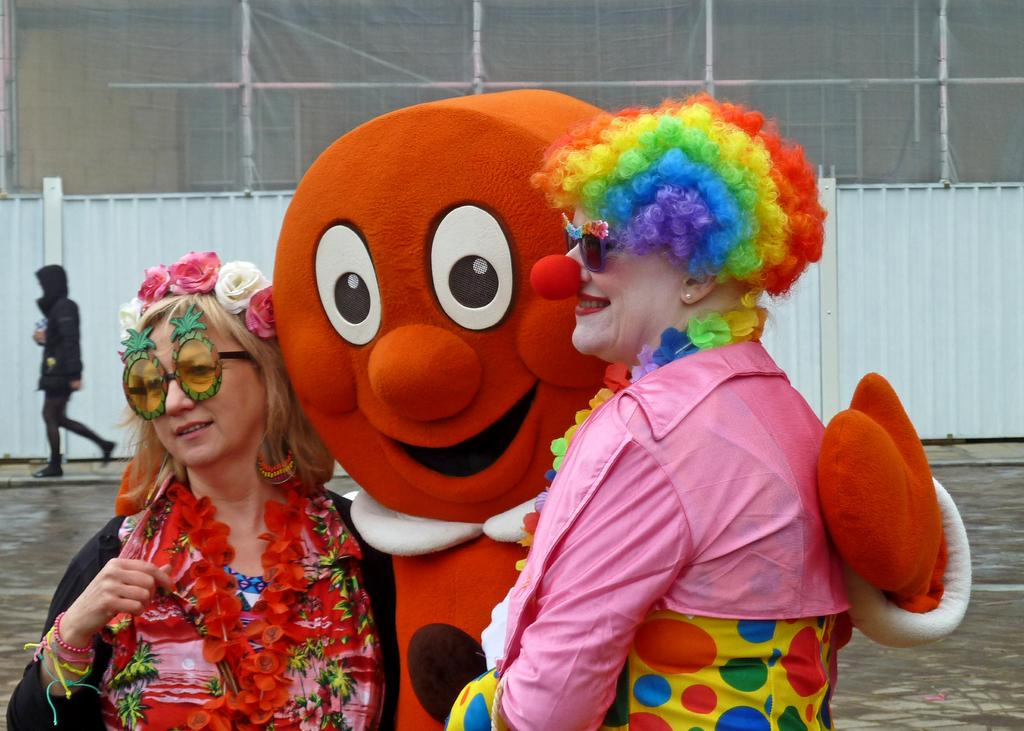What are the people in the image wearing? The people in the image are wearing costumes. Where are the people standing in the image? The people are standing on a pavement. What can be seen in the background of the image? There is a person walking and a wall visible in the background of the image. How many lizards are crawling on the wall in the image? There are no lizards visible in the image; only people wearing costumes, a pavement, a person walking, and a wall are present. 